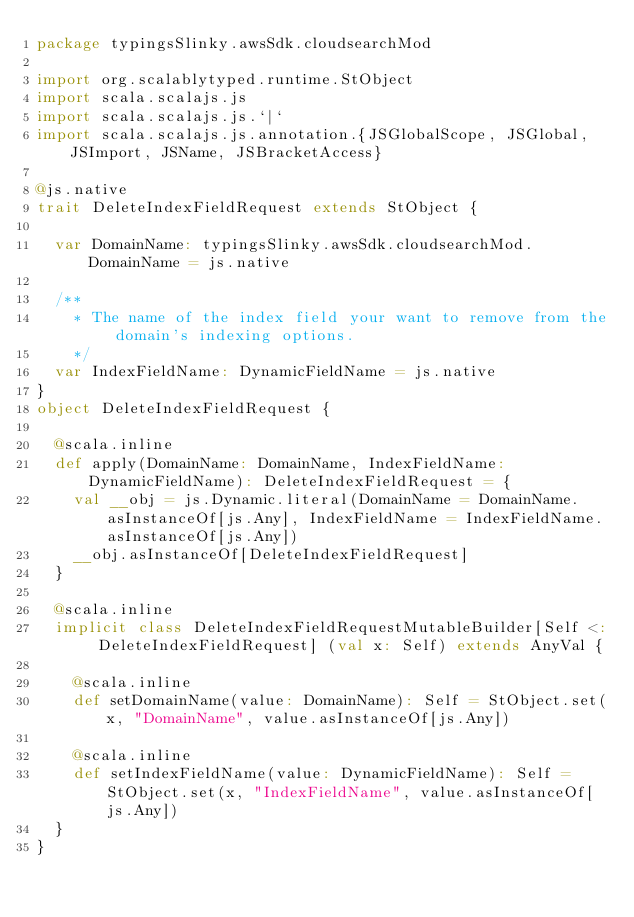<code> <loc_0><loc_0><loc_500><loc_500><_Scala_>package typingsSlinky.awsSdk.cloudsearchMod

import org.scalablytyped.runtime.StObject
import scala.scalajs.js
import scala.scalajs.js.`|`
import scala.scalajs.js.annotation.{JSGlobalScope, JSGlobal, JSImport, JSName, JSBracketAccess}

@js.native
trait DeleteIndexFieldRequest extends StObject {
  
  var DomainName: typingsSlinky.awsSdk.cloudsearchMod.DomainName = js.native
  
  /**
    * The name of the index field your want to remove from the domain's indexing options.
    */
  var IndexFieldName: DynamicFieldName = js.native
}
object DeleteIndexFieldRequest {
  
  @scala.inline
  def apply(DomainName: DomainName, IndexFieldName: DynamicFieldName): DeleteIndexFieldRequest = {
    val __obj = js.Dynamic.literal(DomainName = DomainName.asInstanceOf[js.Any], IndexFieldName = IndexFieldName.asInstanceOf[js.Any])
    __obj.asInstanceOf[DeleteIndexFieldRequest]
  }
  
  @scala.inline
  implicit class DeleteIndexFieldRequestMutableBuilder[Self <: DeleteIndexFieldRequest] (val x: Self) extends AnyVal {
    
    @scala.inline
    def setDomainName(value: DomainName): Self = StObject.set(x, "DomainName", value.asInstanceOf[js.Any])
    
    @scala.inline
    def setIndexFieldName(value: DynamicFieldName): Self = StObject.set(x, "IndexFieldName", value.asInstanceOf[js.Any])
  }
}
</code> 